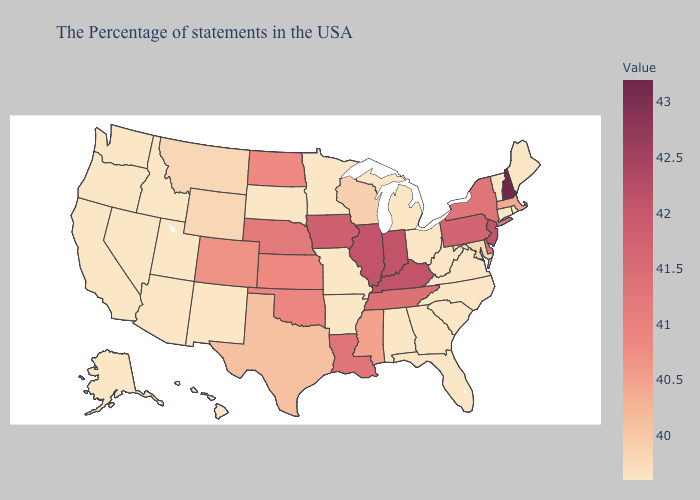Does the map have missing data?
Concise answer only. No. Does South Dakota have the highest value in the MidWest?
Quick response, please. No. Does Montana have a lower value than Louisiana?
Be succinct. Yes. Which states have the lowest value in the Northeast?
Keep it brief. Maine, Rhode Island, Vermont, Connecticut. Does the map have missing data?
Give a very brief answer. No. 